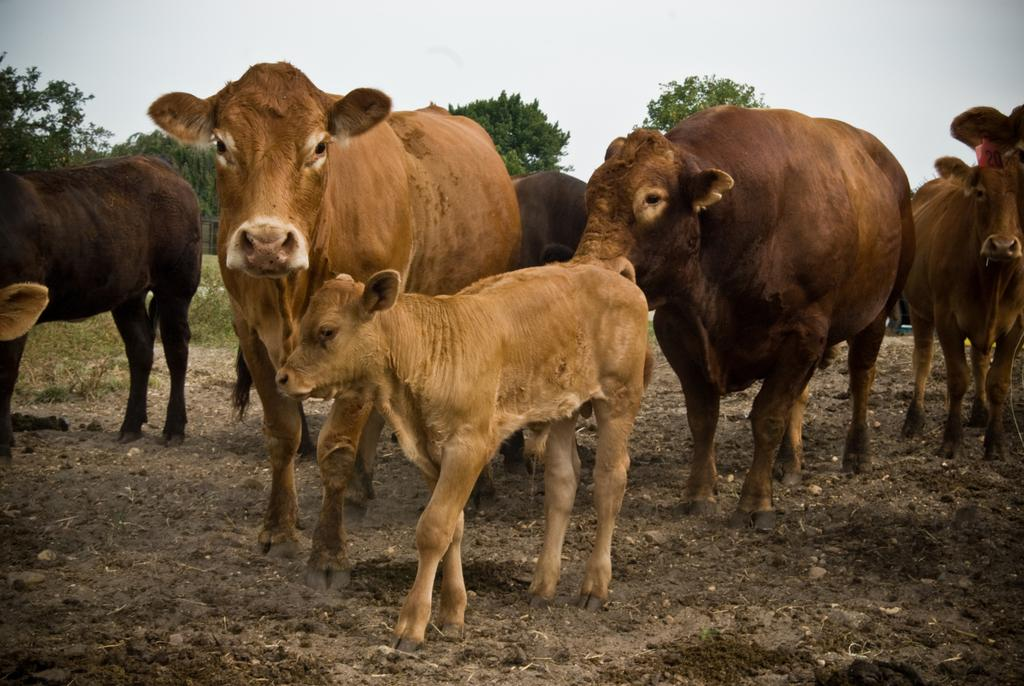What type of living organisms are present in the image? There are animals in the image. What colors are the animals? The animals are brown and cream in color. What is the position of the animals in the image? The animals are standing on the ground. What can be seen in the background of the image? There are trees and the sky visible in the background of the image. What is the color of the trees? The trees are green in color. What type of acoustics can be heard from the animals in the image? There is no sound or acoustics present in the image, as it is a still photograph. How many feet does the laborer have in the image? There is no laborer present in the image; it features animals standing on the ground. 